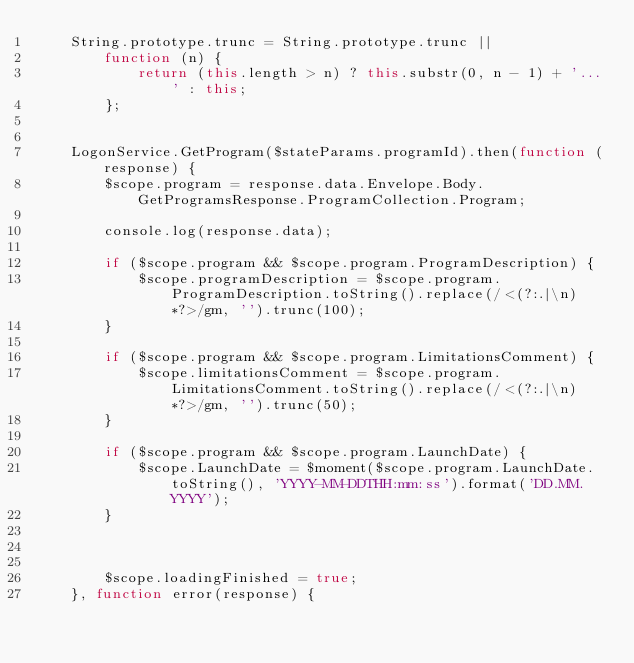<code> <loc_0><loc_0><loc_500><loc_500><_JavaScript_>    String.prototype.trunc = String.prototype.trunc ||
        function (n) {
            return (this.length > n) ? this.substr(0, n - 1) + '...' : this;
        };


    LogonService.GetProgram($stateParams.programId).then(function (response) {
        $scope.program = response.data.Envelope.Body.GetProgramsResponse.ProgramCollection.Program;

        console.log(response.data);

        if ($scope.program && $scope.program.ProgramDescription) {
            $scope.programDescription = $scope.program.ProgramDescription.toString().replace(/<(?:.|\n)*?>/gm, '').trunc(100);
        }

        if ($scope.program && $scope.program.LimitationsComment) {
            $scope.limitationsComment = $scope.program.LimitationsComment.toString().replace(/<(?:.|\n)*?>/gm, '').trunc(50);
        }

        if ($scope.program && $scope.program.LaunchDate) {
            $scope.LaunchDate = $moment($scope.program.LaunchDate.toString(), 'YYYY-MM-DDTHH:mm:ss').format('DD.MM.YYYY');
        }



        $scope.loadingFinished = true;
    }, function error(response) {</code> 